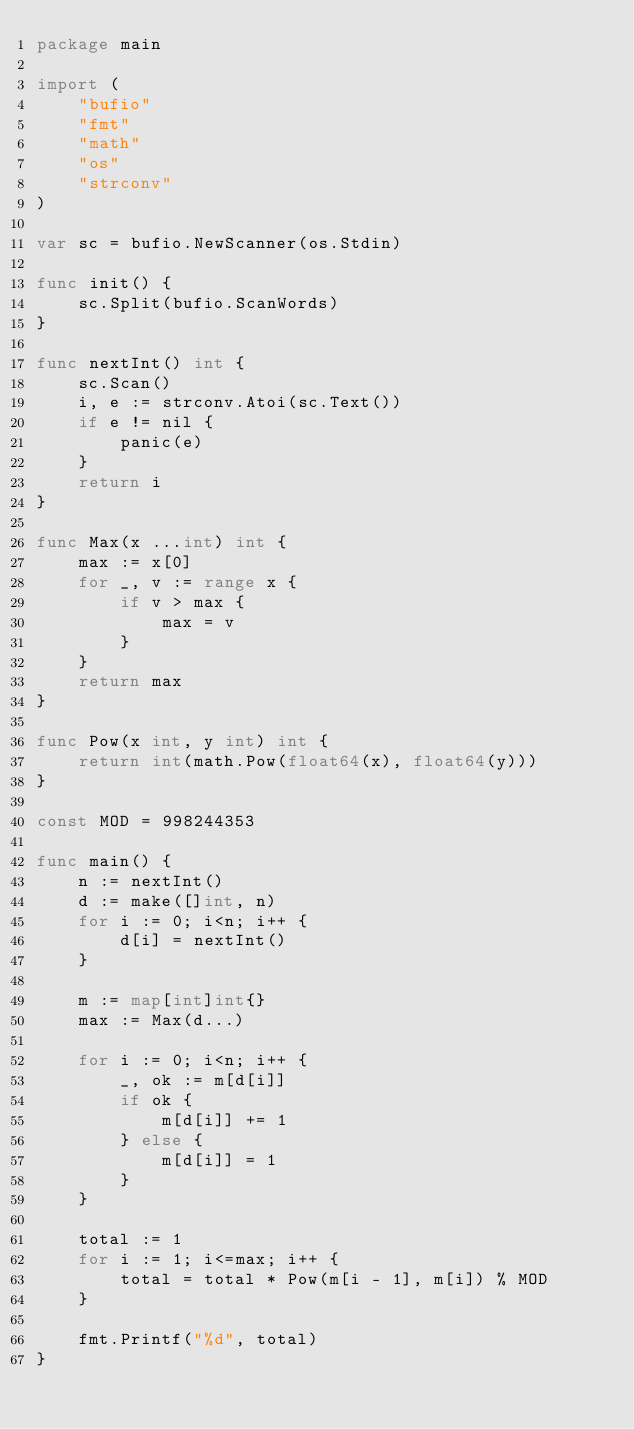Convert code to text. <code><loc_0><loc_0><loc_500><loc_500><_Go_>package main

import (
	"bufio"
	"fmt"
	"math"
	"os"
	"strconv"
)

var sc = bufio.NewScanner(os.Stdin)

func init() {
	sc.Split(bufio.ScanWords)
}

func nextInt() int {
	sc.Scan()
	i, e := strconv.Atoi(sc.Text())
	if e != nil {
		panic(e)
	}
	return i
}

func Max(x ...int) int {
	max := x[0]
	for _, v := range x {
		if v > max {
			max = v
		}
	}
	return max
}

func Pow(x int, y int) int {
	return int(math.Pow(float64(x), float64(y)))
}

const MOD = 998244353

func main() {
	n := nextInt()
	d := make([]int, n)
	for i := 0; i<n; i++ {
		d[i] = nextInt()
	}

	m := map[int]int{}
	max := Max(d...)

	for i := 0; i<n; i++ {
		_, ok := m[d[i]]
		if ok {
			m[d[i]] += 1
		} else {
			m[d[i]] = 1
		}
	}

	total := 1
	for i := 1; i<=max; i++ {
		total = total * Pow(m[i - 1], m[i]) % MOD
	}

	fmt.Printf("%d", total)
}
</code> 